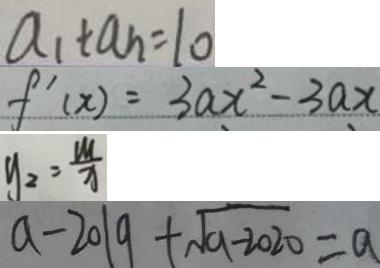<formula> <loc_0><loc_0><loc_500><loc_500>a _ { 1 } + a _ { n } = 1 0 
 f ^ { \prime } ( x ) = 3 a x ^ { 2 } - 3 a x 
 y _ { 2 } = \frac { M } { x } 
 a - 2 0 1 9 + \sqrt { 9 - 2 0 2 0 } = a</formula> 